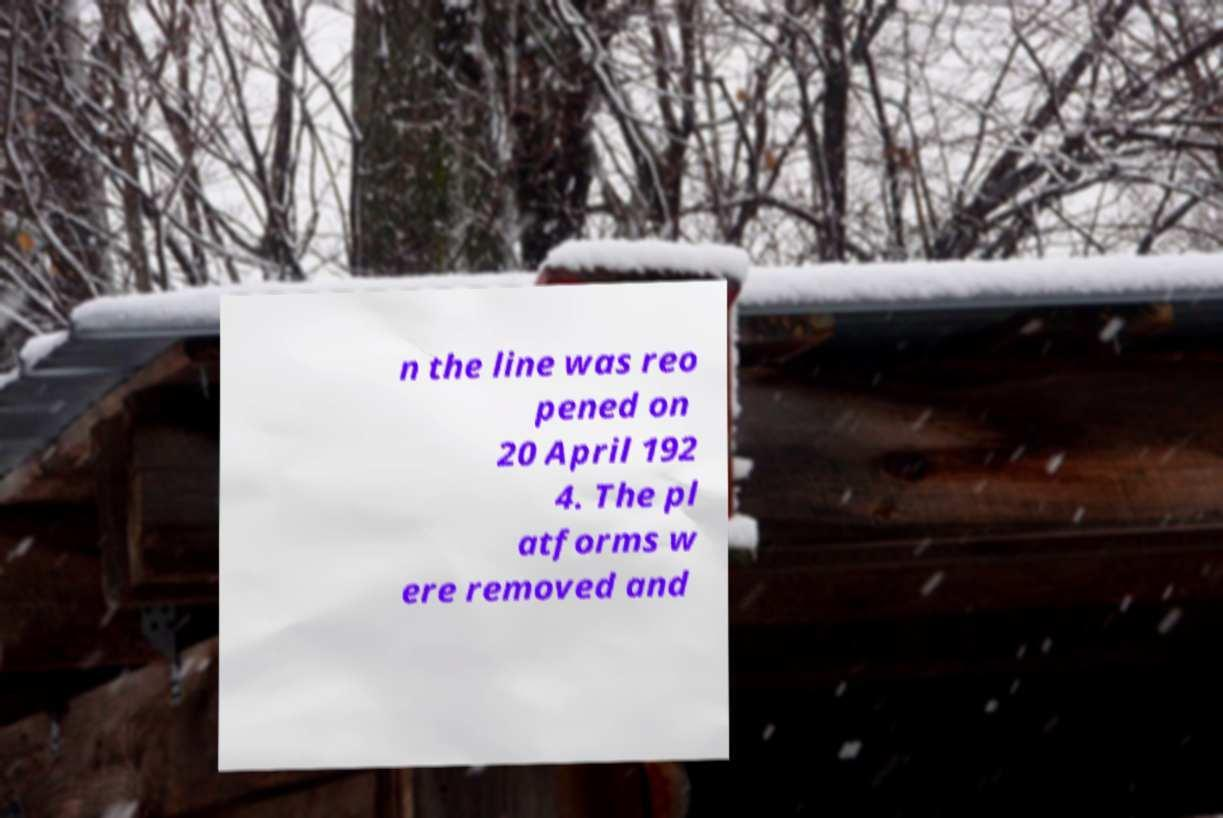I need the written content from this picture converted into text. Can you do that? n the line was reo pened on 20 April 192 4. The pl atforms w ere removed and 